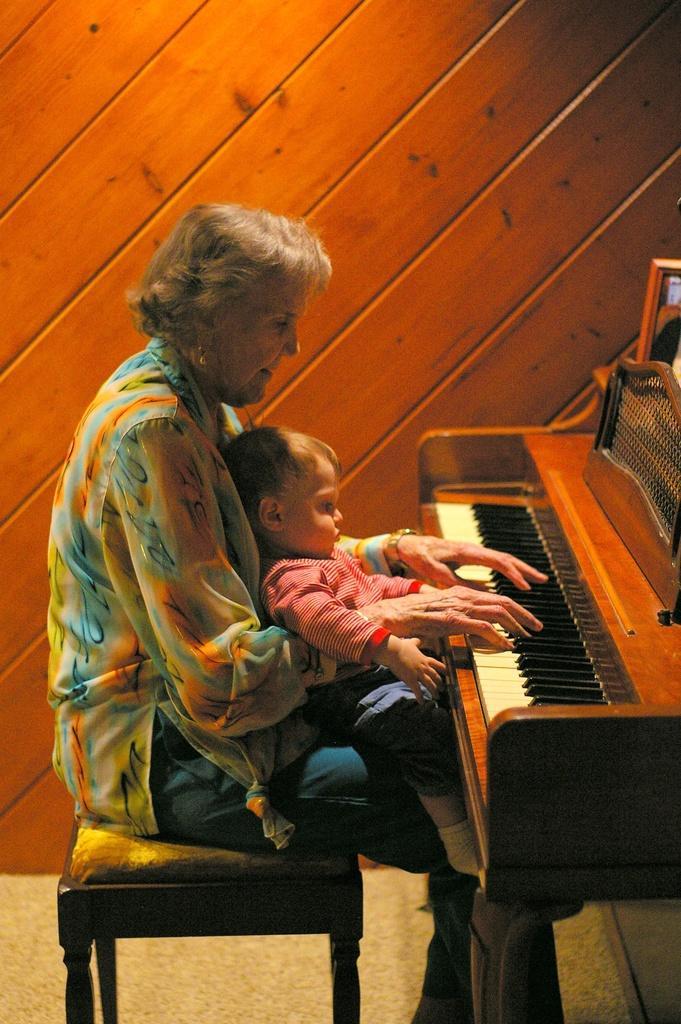Could you give a brief overview of what you see in this image? A lady wearing a floral dress is playing a piano. She is wearing a watch. On her lap, there is a baby sitting. In the background , there is a wooden wall. And she is sitting on a stool. 